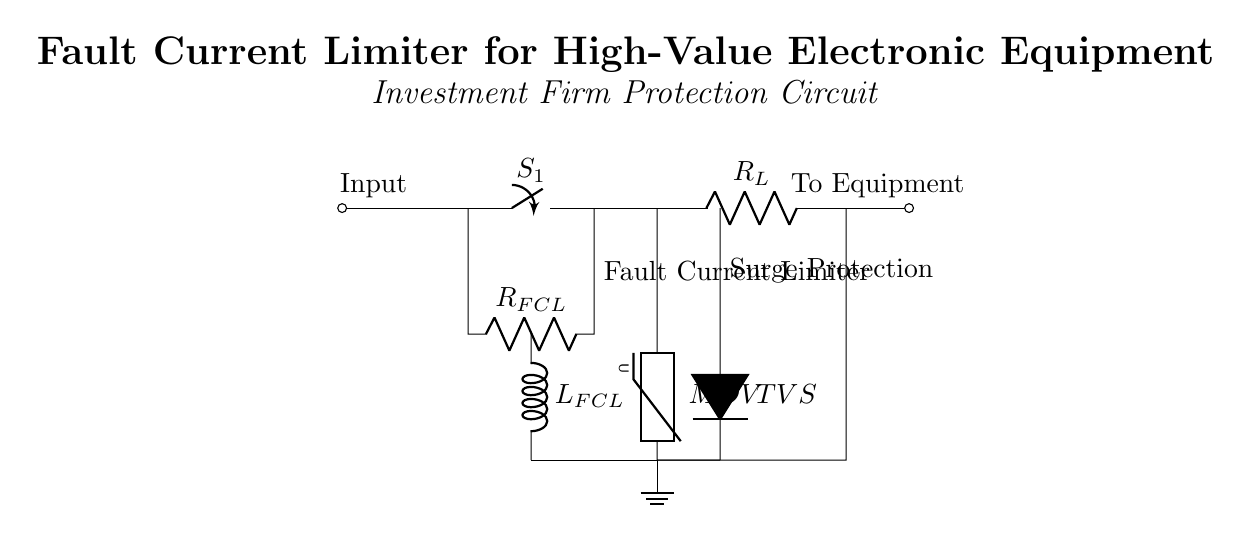What is the component labeled as MOV? The MOV stands for Metal Oxide Varistor, which is used for voltage clamping and surge protection in this circuit.
Answer: Metal Oxide Varistor What type of current does the Fault Current Limiter address? The Fault Current Limiter addresses abnormal or fault currents, which can damage sensitive electronic equipment by limiting the amount of current that flows through them during unusual conditions.
Answer: Fault current What is the purpose of the inductance labeled as L_FCL? The inductor, labeled as L_FCL, helps in limiting the rate of current change and aids in the performance of the fault current limiter by providing reactance against sudden spikes in current.
Answer: Current change limiting How many protective elements are included in the circuit? The protective elements include three components: the fault current limiter, varistor, and transient voltage suppression diode, making a total of three protective components.
Answer: Three What happens to excess voltage when it reaches the varistor (MOV)? When excess voltage reaches the varistor, it clamps or diverts the over-voltage to the ground, thus protecting the connected equipment from voltage surges.
Answer: It clamps excess voltage What is the configuration of the switch labeled S_1? The switch S_1 is in a series configuration, which means it can open or close the circuit, enabling or disabling the flow of current to the downstream components.
Answer: Series configuration What is the primary function of the circuit as a whole? The primary function of the circuit is to protect high-value electronic equipment from sudden surges and faults by limiting current and clamping excess voltage.
Answer: Equipment protection 